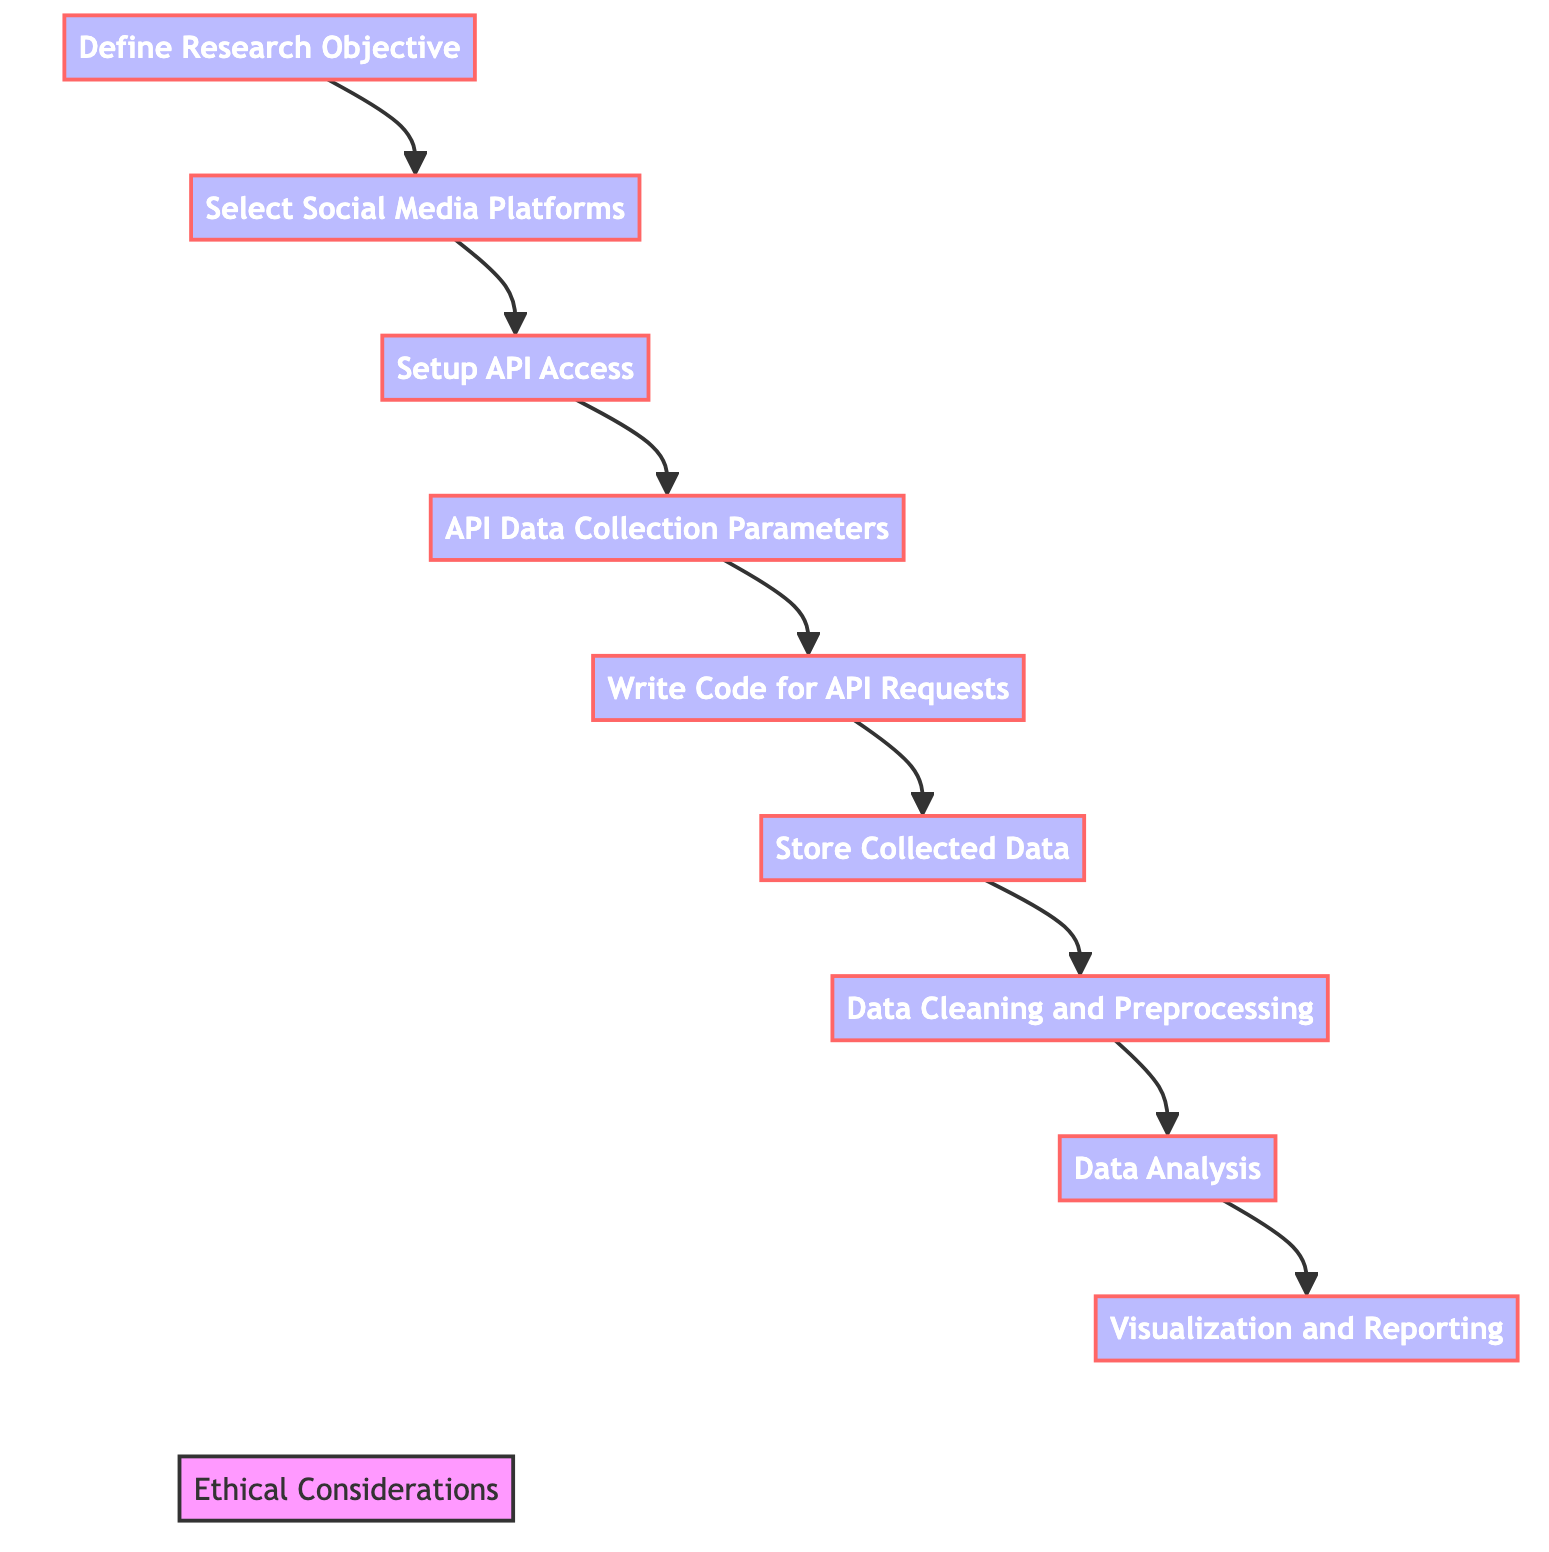what is the first step in the diagram? The first step in the diagram is to "Define Research Objective," which sets the foundation for the research questions and scope.
Answer: Define Research Objective how many main process steps are in the flowchart? There are eight main process steps in the flowchart, specifically from "Define Research Objective" to "Visualization and Reporting."
Answer: eight what step comes directly after "Setup API Access"? The step directly after "Setup API Access" is "API Data Collection Parameters," which involves setting relevant parameters for data collection.
Answer: API Data Collection Parameters which step focuses on databases or data storage? The step that focuses on databases or data storage is "Store Collected Data," where the social media data is saved using a suitable storage solution.
Answer: Store Collected Data how is "Ethical Considerations" related to the other steps in the diagram? "Ethical Considerations" is related to all other steps as a surrounding concern, ensuring that ethical guidelines are adhered to throughout the research process.
Answer: surrounded by all other steps what is the purpose of the "Data Cleaning and Preprocessing" step? The purpose of "Data Cleaning and Preprocessing" is to prepare the collected dataset for analysis by removing duplicates and irrelevant content.
Answer: prepare the dataset which step has a specific focus on tools for analysis? The step that has a specific focus on tools for analysis is "Data Analysis," where tools like Pandas, NumPy, or R are used to analyze the cleaned data.
Answer: Data Analysis what do the arrows between the steps represent? The arrows between the steps represent the flow of the research process from one step to the next, indicating the order of operations required for data collection and analysis.
Answer: flow of the research process which platform is *not* explicitly mentioned in the "Select Social Media Platforms" step? Specific platforms like TikTok or Snapchat are *not* explicitly mentioned, as the step lists Twitter, Facebook, and Instagram only.
Answer: TikTok or Snapchat 